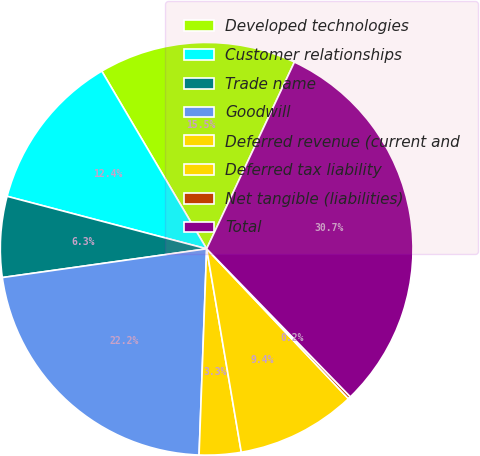<chart> <loc_0><loc_0><loc_500><loc_500><pie_chart><fcel>Developed technologies<fcel>Customer relationships<fcel>Trade name<fcel>Goodwill<fcel>Deferred revenue (current and<fcel>Deferred tax liability<fcel>Net tangible (liabilities)<fcel>Total<nl><fcel>15.48%<fcel>12.42%<fcel>6.32%<fcel>22.19%<fcel>3.27%<fcel>9.37%<fcel>0.21%<fcel>30.74%<nl></chart> 